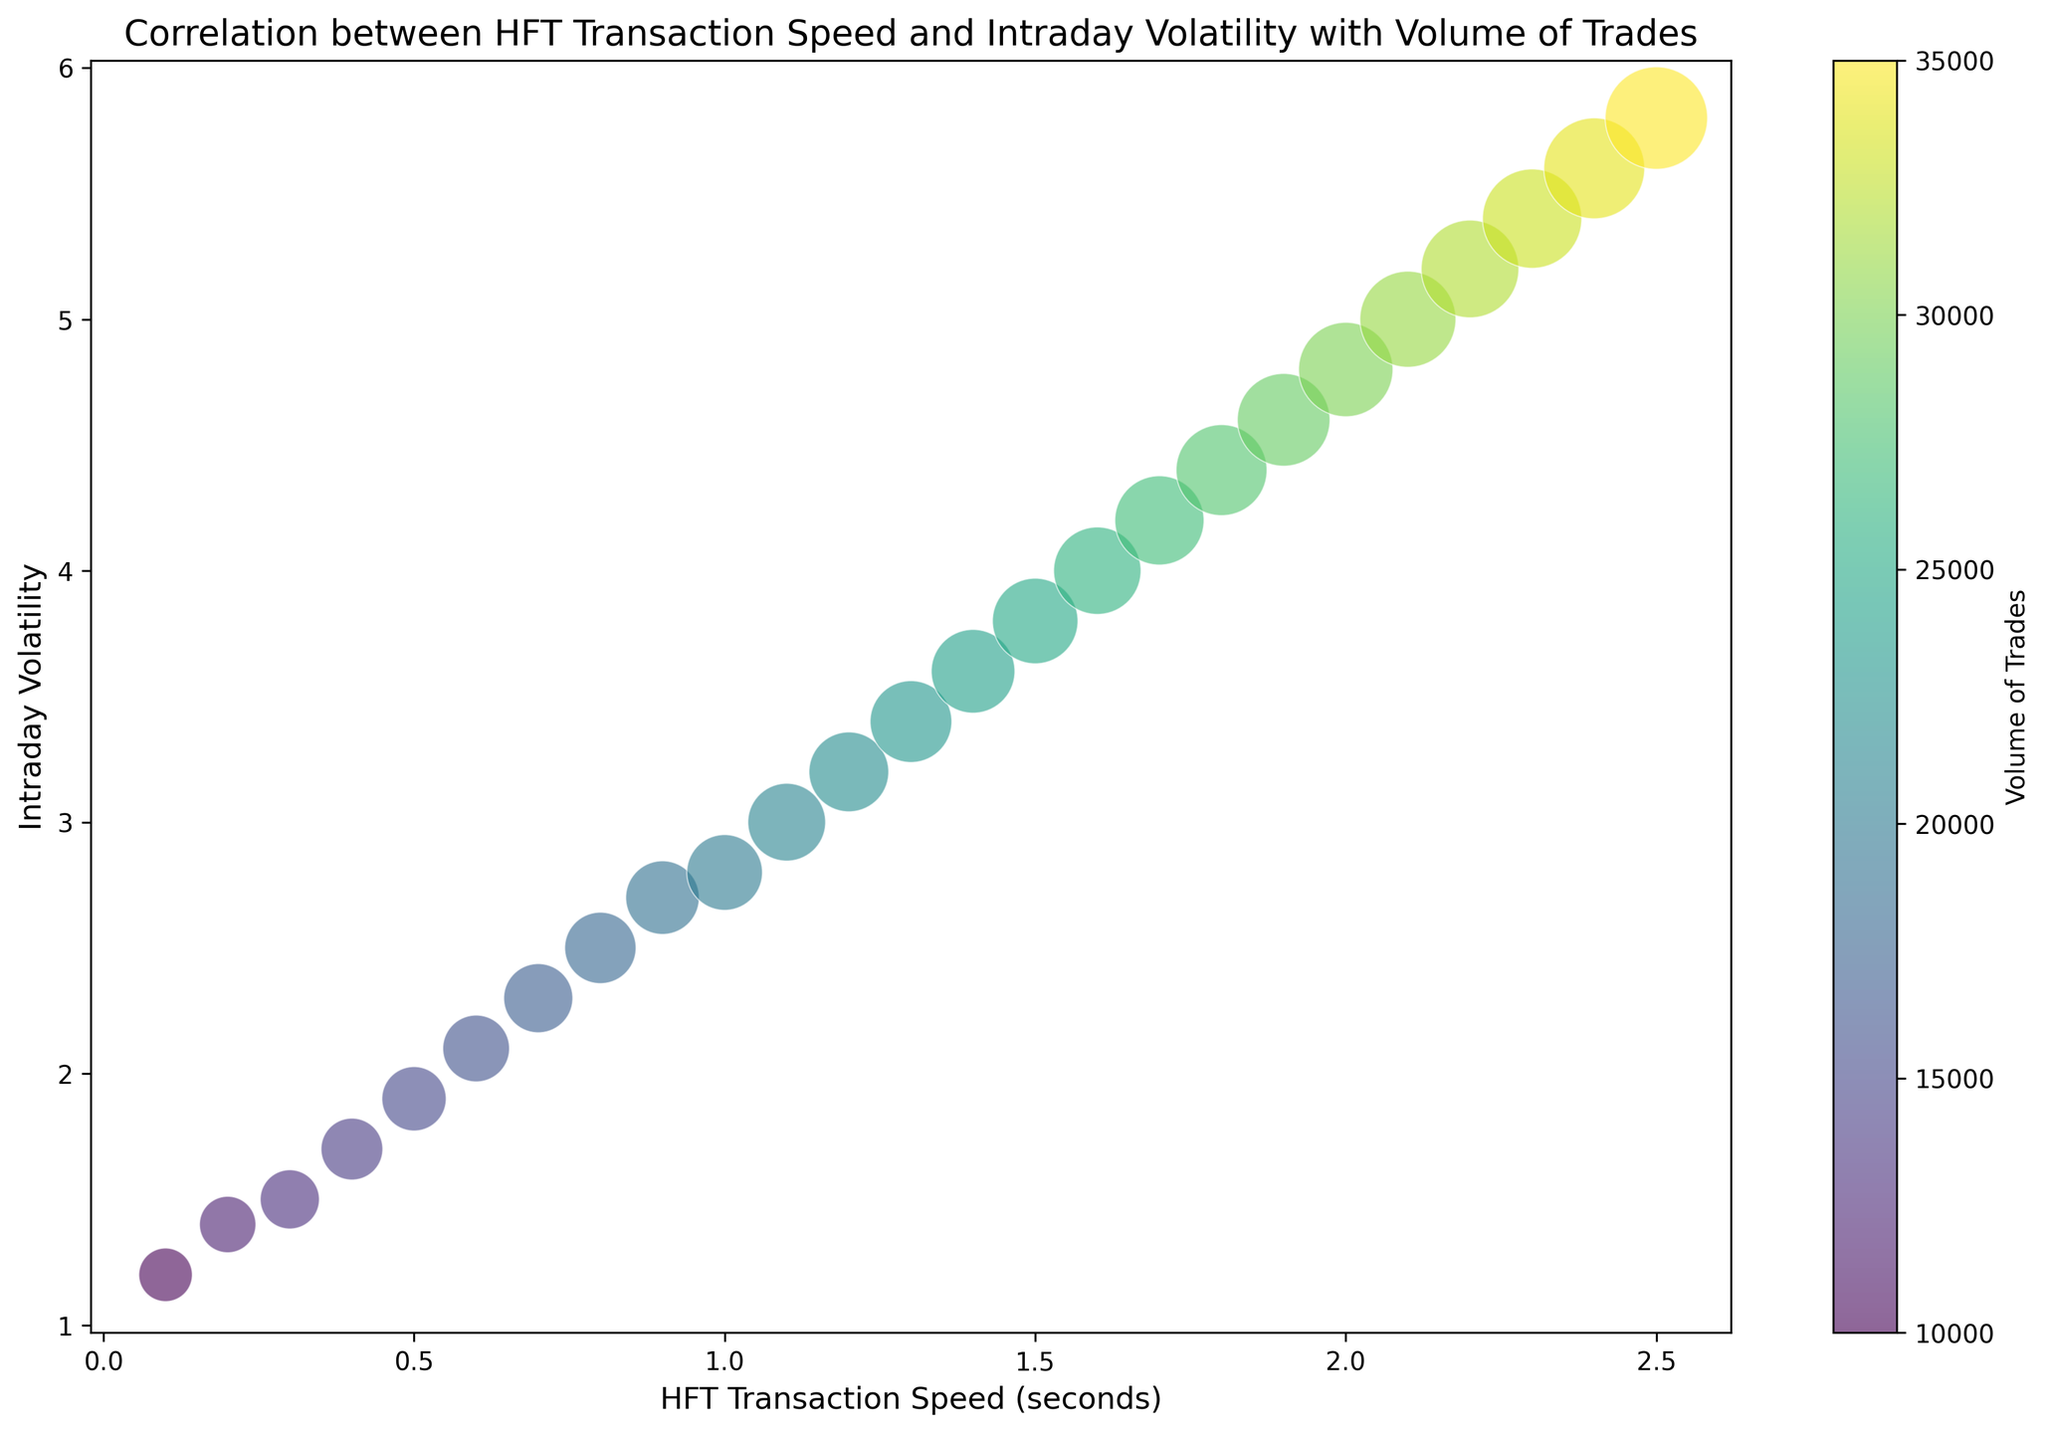What's the overall trend between HFT Transaction Speed and Intraday Volatility? The figure shows a positive relationship between HFT Transaction Speed (x-axis) and Intraday Volatility (y-axis). As HFT Transaction Speed increases, Intraday Volatility also increases.
Answer: Positive relationship Which data point (bubble) has the highest intraday volatility and what is its HFT transaction speed? The bubble at the uppermost point on the y-axis has the highest intraday volatility of 5.8, and it corresponds to an HFT transaction speed of 2.5 seconds.
Answer: 2.5 seconds Comparing the bubbles, which HFT Transaction Speed corresponds to the largest Volume of Trades? The colorbar indicates that the highest volume of trades is represented by the darkest color. The bubble at HFT transaction speed of 2.5 corresponds to the highest volume of trades (35000).
Answer: 2.5 seconds What is the Intraday Volatility difference between the HFT transaction speed of 0.1 and 2.5? The Intraday Volatility at HFT transaction speed 0.1 is 1.2, and at 2.5 it is 5.8. The difference is calculated as 5.8 - 1.2.
Answer: 4.6 What is the average HFT Transaction Speed for Intraday Volatility values of 2.8, 4.8, and 5.8? The HFT Transaction Speeds corresponding to these Intraday Volatility values are 1.0, 2.0, and 2.5 respectively. The average is calculated as (1.0 + 2.0 + 2.5) / 3.
Answer: 1.83 Which intraday volatility value is associated with the HFT transaction speed that has the smallest bubble size? The smallest bubble represents the smallest HFT Transaction Speed, which is 0.1, and it is associated with an Intraday Volatility of 1.2.
Answer: 1.2 How does the volume of trades change as the intraday volatility increases from 1.2 to 5.8? As intraday volatility increases from 1.2 to 5.8, the color intensity of the bubbles increases, indicating an increase in the volume of trades. The volume of trades ranges from 10000 at 1.2 to 35000 at 5.8.
Answer: Increases 